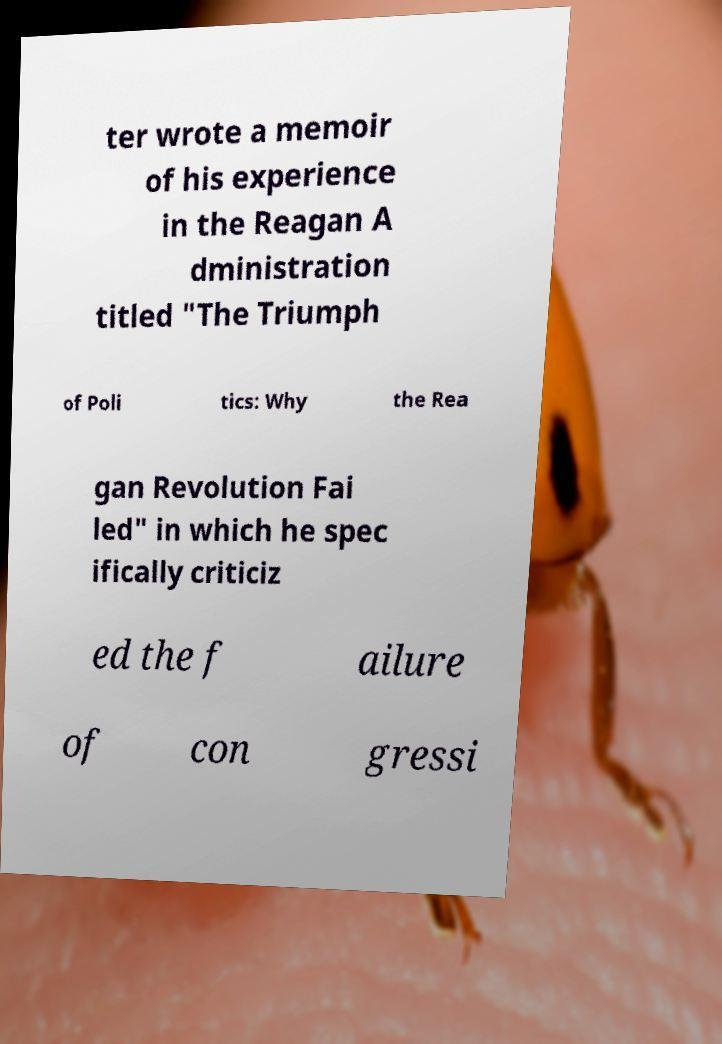For documentation purposes, I need the text within this image transcribed. Could you provide that? ter wrote a memoir of his experience in the Reagan A dministration titled "The Triumph of Poli tics: Why the Rea gan Revolution Fai led" in which he spec ifically criticiz ed the f ailure of con gressi 